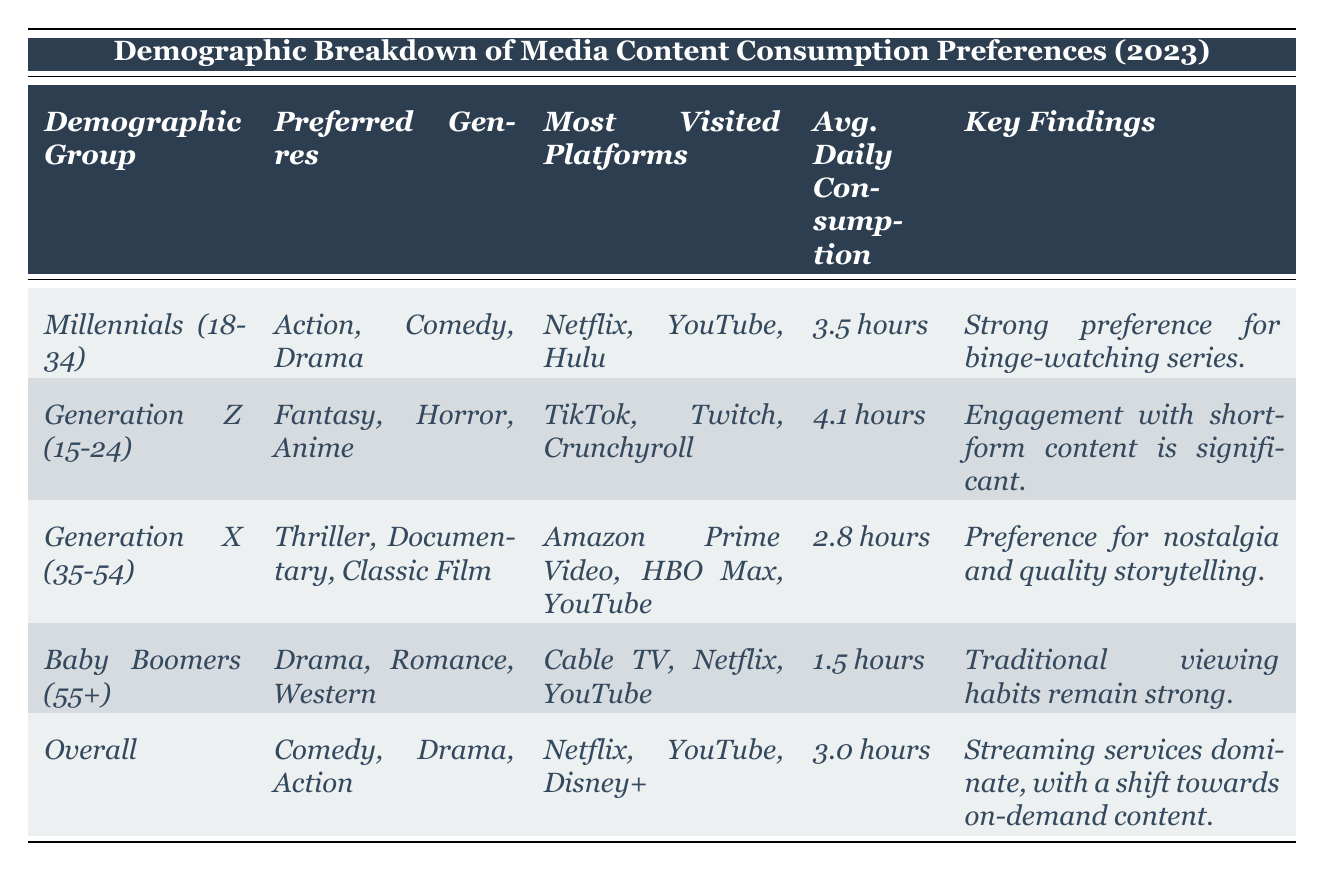What are the preferred genres of Generation Z? The table lists "Preferred Genres" for each demographic group. For Generation Z (15-24), the preferred genres are Fantasy, Horror, and Anime.
Answer: Fantasy, Horror, Anime Which demographic group has the highest average daily consumption hours? By comparing the "Avg. Daily Consumption" column, Generation Z (4.1 hours) has the highest average daily consumption compared to Millennials (3.5 hours), Generation X (2.8 hours), and Baby Boomers (1.5 hours).
Answer: Generation Z (15-24) Do Baby Boomers have a preference for streaming platforms over traditional TV? The "Most Visited Platforms" for Baby Boomers include Cable TV, suggesting they retain traditional viewing habits rather than favoring streaming platforms like Netflix or YouTube more predominantly as other groups do.
Answer: No What is the average daily consumption hours across all demographic groups? To find the average consumption, add the daily hours (3.5 + 4.1 + 2.8 + 1.5 + 3.0 = 15.9) and divide by the number of groups (5). The average is 15.9 / 5 = 3.18 hours, rounded gives approximately 3.0 hours in the overall section which is confirmed in the table.
Answer: 3.0 hours Which platforms are most visited by Millennials? The table specifies that Millennials (18-34) visit Netflix, YouTube, and Hulu most frequently.
Answer: Netflix, YouTube, Hulu Are unspecified platforms for each demographic consistently different? Each demographic group has listed unique platforms, as Millennials favor Netflix and Hulu, while Baby Boomers lean towards Cable TV and Netflix, indicating distinct preferences.
Answer: Yes What genre do Baby Boomers preferred that other groups also enjoy? The genre "Drama" appears in the preferences of both Baby Boomers and the Overall group, indicating a common preference.
Answer: Drama Is there a strong consumption of on-demand content across all demographics? The "Key Findings" for the Overall group indicates that streaming services dominate and there is a shift toward on-demand content, suggesting a general trend.
Answer: Yes How many hours do Millennials consume media daily compared to Baby Boomers? Millennials consume an average of 3.5 hours daily whereas Baby Boomers consume 1.5 hours. The difference is 3.5 - 1.5 = 2.0 hours, indicating Millennials consume significantly more.
Answer: 2.0 hours more Which demographic has the strongest inclination toward short-form content? Generation Z is noted for significant engagement with short-form content in their key findings, which suggests they are the most inclined toward this type of media.
Answer: Generation Z (15-24) 